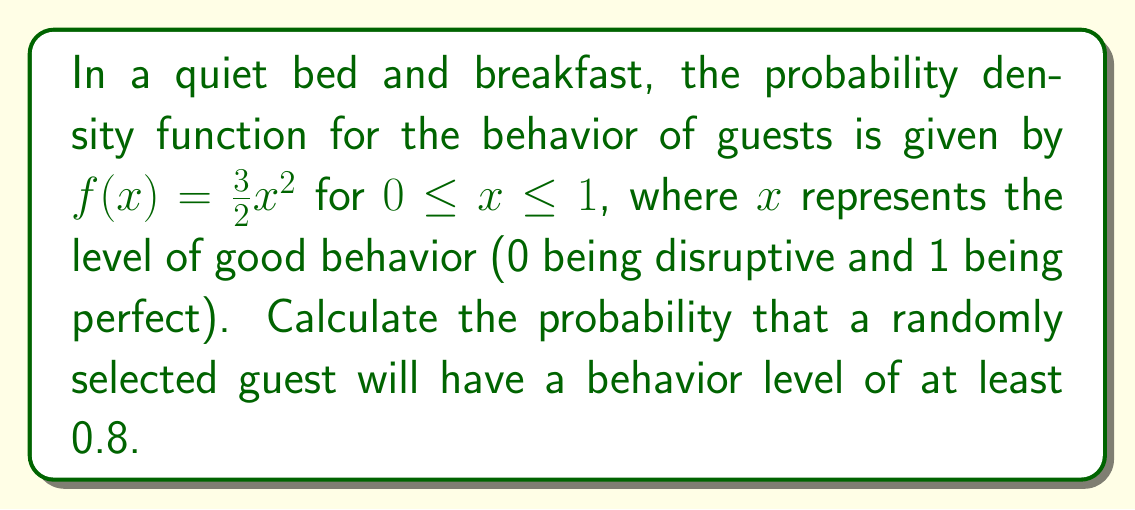Can you answer this question? To solve this problem, we need to integrate the probability density function from 0.8 to 1. This will give us the probability of a guest having a behavior level between 0.8 and 1.

Step 1: Set up the integral
$$P(x \geq 0.8) = \int_{0.8}^1 f(x) dx = \int_{0.8}^1 \frac{3}{2}x^2 dx$$

Step 2: Integrate the function
$$\int_{0.8}^1 \frac{3}{2}x^2 dx = \frac{3}{2} \int_{0.8}^1 x^2 dx = \frac{3}{2} \left[\frac{x^3}{3}\right]_{0.8}^1$$

Step 3: Evaluate the integral
$$\frac{3}{2} \left[\frac{x^3}{3}\right]_{0.8}^1 = \frac{3}{2} \left(\frac{1^3}{3} - \frac{0.8^3}{3}\right) = \frac{3}{2} \left(\frac{1}{3} - \frac{0.512}{3}\right)$$

Step 4: Simplify
$$\frac{3}{2} \left(\frac{1}{3} - \frac{0.512}{3}\right) = \frac{1}{2} - \frac{0.768}{2} = \frac{0.232}{2} = 0.116$$

Therefore, the probability of encountering a guest with a behavior level of at least 0.8 is 0.116 or 11.6%.
Answer: 0.116 